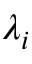<formula> <loc_0><loc_0><loc_500><loc_500>\lambda _ { i }</formula> 